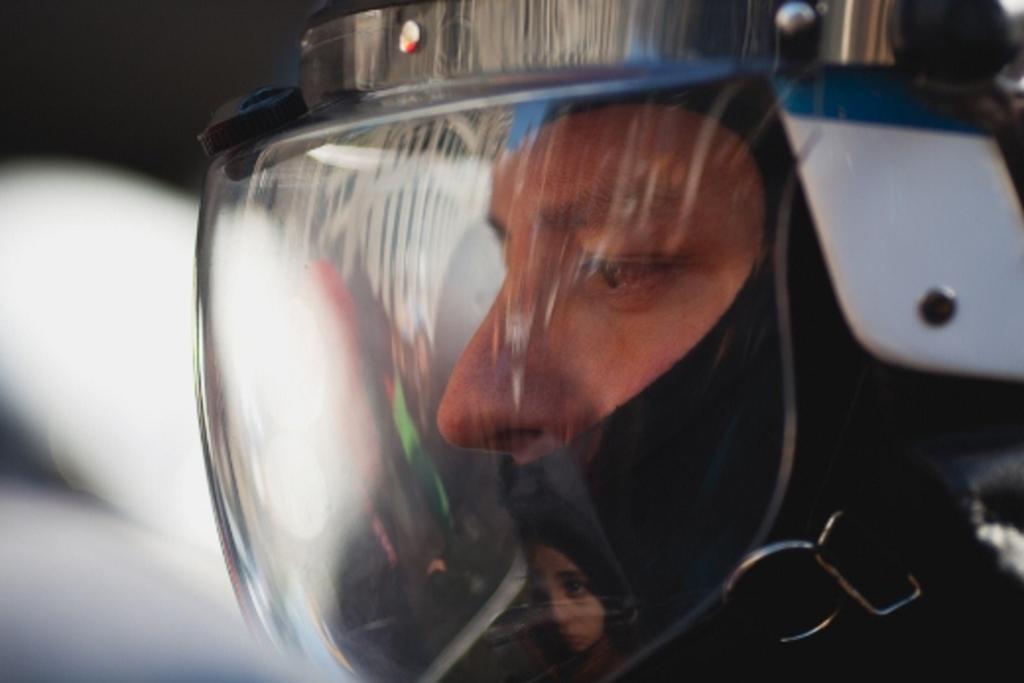How would you summarize this image in a sentence or two? In this image we can see a person wearing a helmet. 